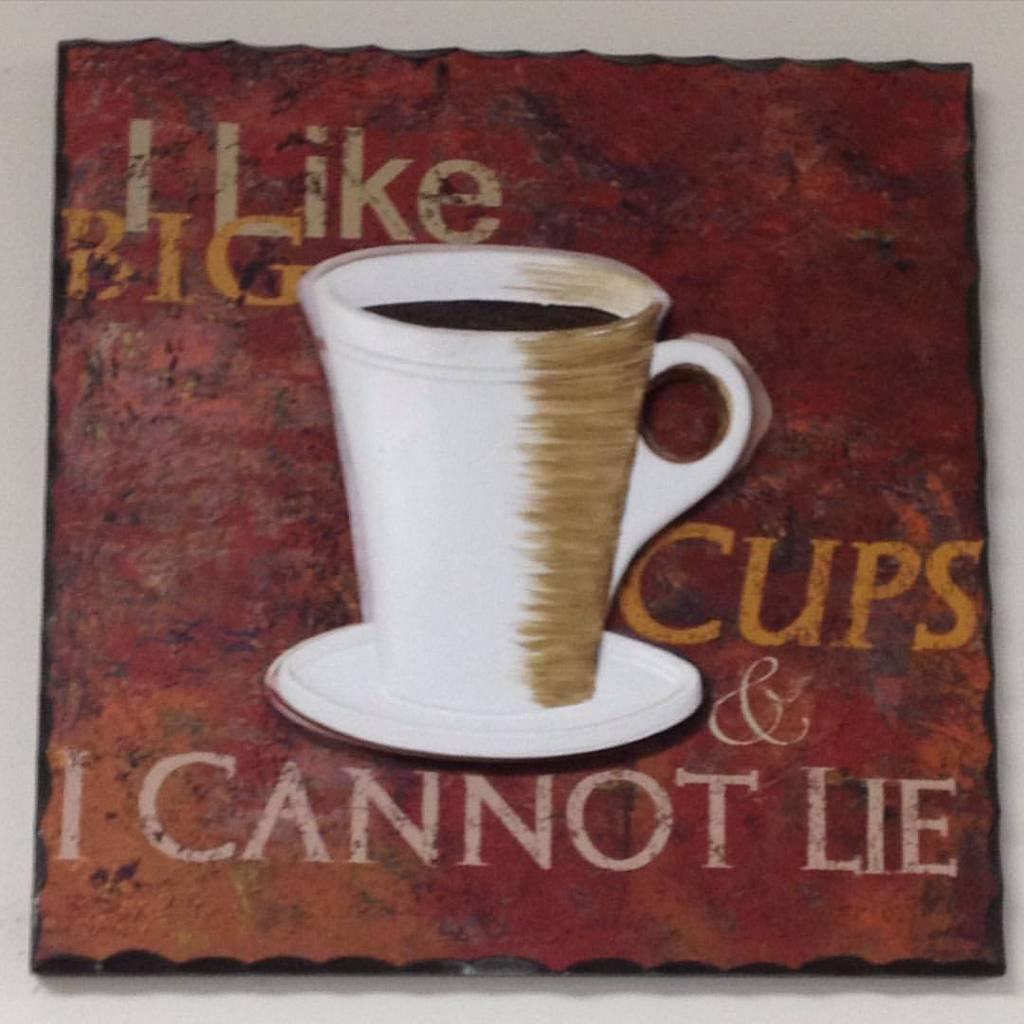Provide a one-sentence caption for the provided image. I painting of a coffee mug with the caption "I like big cups & I cannot lie". 